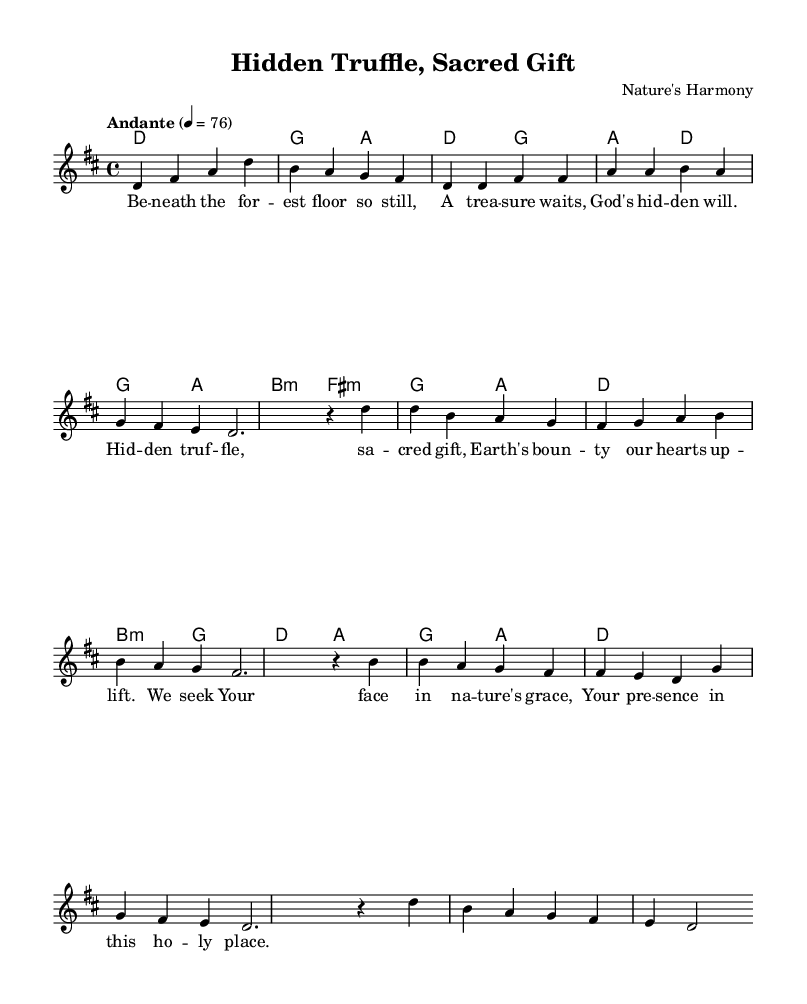What is the key signature of this music? The key signature is D major, which includes two sharps: F# and C#.
Answer: D major What is the time signature of this music? The time signature is indicated by the "4/4" at the beginning of the score, which means there are four beats in each measure.
Answer: 4/4 What is the tempo marking of the music? The tempo marking is "Andante," which is an indication to perform the piece at a moderate pace.
Answer: Andante How many measures are there in the chorus? The chorus consists of four measures, as can be counted in the corresponding section of the notation.
Answer: 4 What is the title of this piece? The title is shown at the top of the sheet music and refers to the overarching theme or subject of the piece.
Answer: Hidden Truffle, Sacred Gift What do the lyrics in the bridge section express? The lyrics emphasize seeking a divine presence in nature, highlighting the connection between spirituality and the natural world.
Answer: Seeking divine presence What type of harmony is primarily used in the chorus? The harmony in the chorus utilizes root position and first inversion chords, commonly used in religious music to create a supportive backdrop for the melody.
Answer: Root position and first inversion chords 